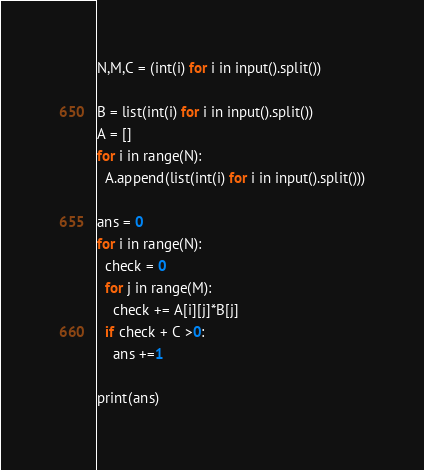Convert code to text. <code><loc_0><loc_0><loc_500><loc_500><_Python_>N,M,C = (int(i) for i in input().split())

B = list(int(i) for i in input().split())
A = []
for i in range(N):
  A.append(list(int(i) for i in input().split()))

ans = 0
for i in range(N):
  check = 0
  for j in range(M):
    check += A[i][j]*B[j]
  if check + C >0:
    ans +=1

print(ans)
</code> 